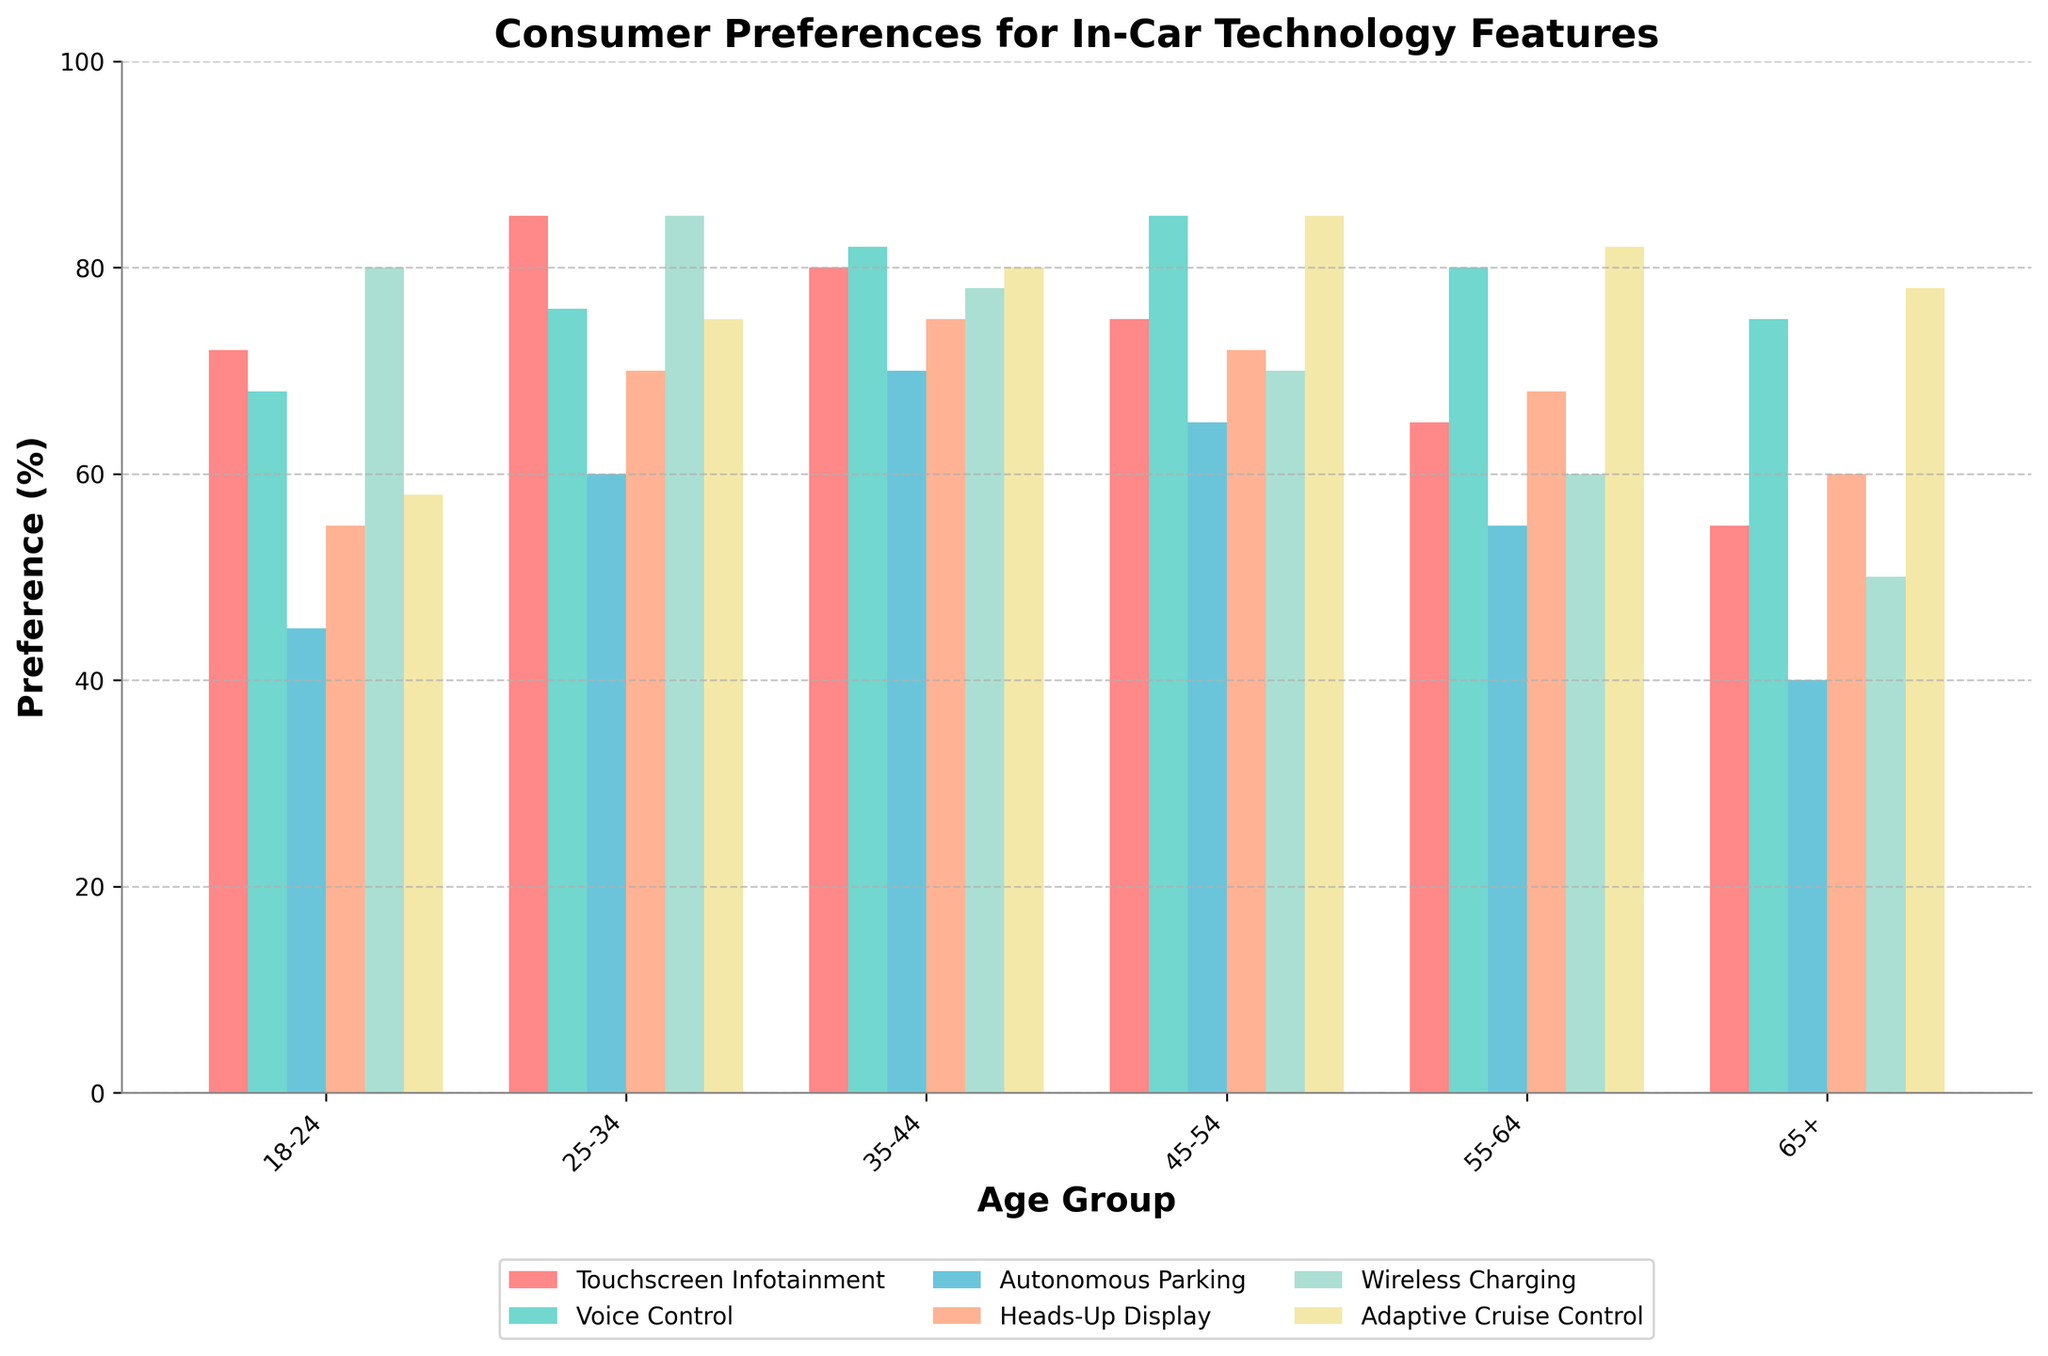What's the most preferred in-car technology feature for the 25-34 age group? Look at the bar heights for the 25-34 age group and identify the tallest bar. The feature with the highest preference percentage is the most preferred.
Answer: Wireless Charging Which age group shows the lowest preference for Adaptive Cruise Control? Check the bar heights for Adaptive Cruise Control across all age groups. The age group with the shortest bar indicates the lowest preference for this feature.
Answer: 18-24 Which two features have the smallest difference in preference among the 18-24 age group? Compare the bar heights for each feature within the 18-24 age group and calculate the differences. The pair with the smallest difference is the answer.
Answer: Touchscreen Infotainment and Voice Control What is the average preference for Heads-Up Display across all age groups? Sum the preference percentages for Heads-Up Display across all age groups and divide by the number of age groups (6). Calculation: (55+70+75+72+68+60)/6
Answer: 66.7 Which feature shows a consistent increase in preference with age up to the 45-54 group, but then decreases for older groups? Examine the bars for each feature across age groups. Identify the one that increases consistently up to the 45-54 group and then decreases.
Answer: Adaptive Cruise Control By how much does the preference for Autonomous Parking in the 35-44 age group exceed that in the 65+ age group? Subtract the preference percentage of Autonomous Parking for the 65+ age group from that of the 35-44 age group. Calculation: 70 - 40
Answer: 30 For which age group is Wireless Charging the most preferred feature? Look at the bar heights for Wireless Charging across all age groups. The age group with the tallest bar for this feature is the answer.
Answer: 18-24 What is the average preference for all features in the 45-54 age group? Sum the preference percentages for all features in the 45-54 age group and divide by the number of features (6). Calculation: (75+85+65+72+70+85)/6
Answer: 75.3 Which two features have the greatest difference in preference for the 55-64 age group? Compare the bar heights for each feature within the 55-64 age group and calculate the differences. The pair with the greatest difference is the answer.
Answer: Wireless Charging and Touchscreen Infotainment How much does the preference for Voice Control vary between the youngest (18-24) and oldest (65+) age groups? Subtract the preference percentage of Voice Control for the 65+ age group from that of the 18-24 age group. Calculation: 68 - 75
Answer: -7 